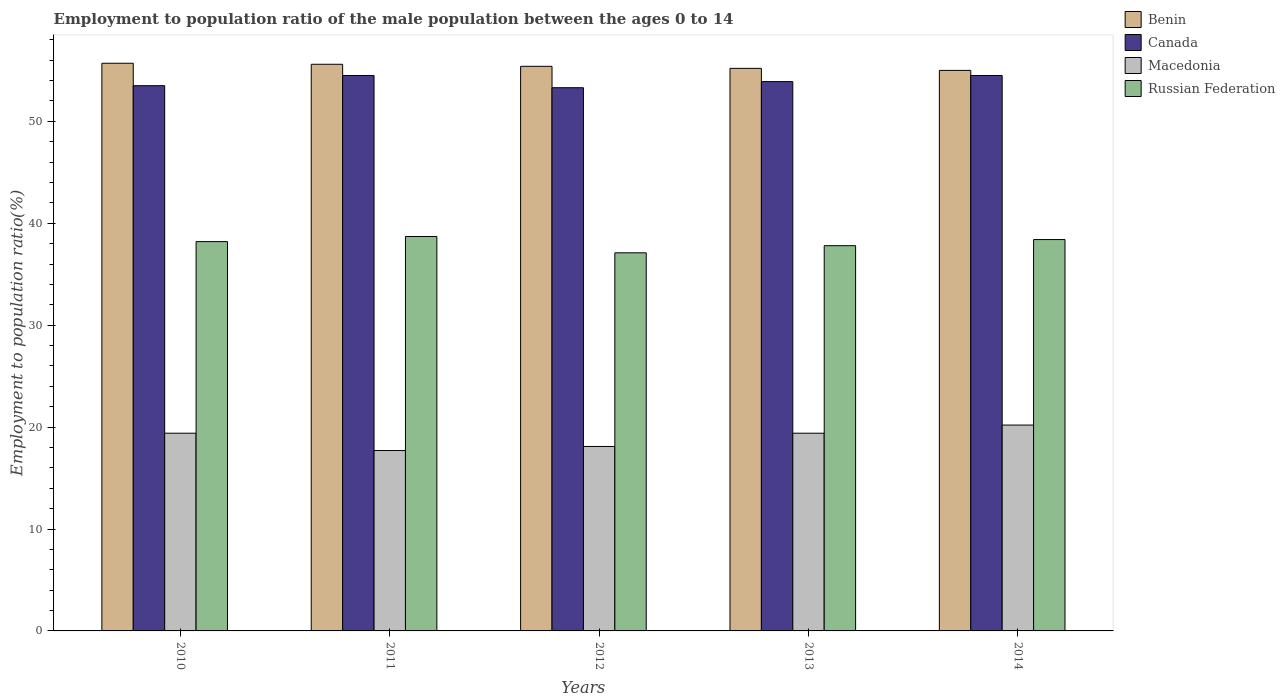How many different coloured bars are there?
Offer a terse response. 4. Are the number of bars per tick equal to the number of legend labels?
Your answer should be very brief. Yes. Are the number of bars on each tick of the X-axis equal?
Offer a very short reply. Yes. How many bars are there on the 1st tick from the left?
Keep it short and to the point. 4. How many bars are there on the 5th tick from the right?
Keep it short and to the point. 4. What is the label of the 3rd group of bars from the left?
Make the answer very short. 2012. What is the employment to population ratio in Benin in 2013?
Ensure brevity in your answer.  55.2. Across all years, what is the maximum employment to population ratio in Macedonia?
Offer a very short reply. 20.2. In which year was the employment to population ratio in Russian Federation maximum?
Keep it short and to the point. 2011. In which year was the employment to population ratio in Benin minimum?
Your answer should be compact. 2014. What is the total employment to population ratio in Russian Federation in the graph?
Offer a very short reply. 190.2. What is the difference between the employment to population ratio in Russian Federation in 2012 and that in 2013?
Your answer should be very brief. -0.7. What is the difference between the employment to population ratio in Canada in 2010 and the employment to population ratio in Benin in 2012?
Make the answer very short. -1.9. What is the average employment to population ratio in Benin per year?
Give a very brief answer. 55.38. In the year 2014, what is the difference between the employment to population ratio in Macedonia and employment to population ratio in Canada?
Your response must be concise. -34.3. In how many years, is the employment to population ratio in Benin greater than 30 %?
Your answer should be compact. 5. What is the ratio of the employment to population ratio in Canada in 2012 to that in 2014?
Give a very brief answer. 0.98. Is the difference between the employment to population ratio in Macedonia in 2013 and 2014 greater than the difference between the employment to population ratio in Canada in 2013 and 2014?
Make the answer very short. No. What is the difference between the highest and the second highest employment to population ratio in Canada?
Provide a short and direct response. 0. What is the difference between the highest and the lowest employment to population ratio in Benin?
Give a very brief answer. 0.7. In how many years, is the employment to population ratio in Canada greater than the average employment to population ratio in Canada taken over all years?
Make the answer very short. 2. Is it the case that in every year, the sum of the employment to population ratio in Russian Federation and employment to population ratio in Canada is greater than the sum of employment to population ratio in Macedonia and employment to population ratio in Benin?
Keep it short and to the point. No. What does the 3rd bar from the left in 2010 represents?
Ensure brevity in your answer.  Macedonia. What does the 1st bar from the right in 2011 represents?
Ensure brevity in your answer.  Russian Federation. Is it the case that in every year, the sum of the employment to population ratio in Macedonia and employment to population ratio in Russian Federation is greater than the employment to population ratio in Benin?
Give a very brief answer. No. How many bars are there?
Your answer should be compact. 20. Are the values on the major ticks of Y-axis written in scientific E-notation?
Keep it short and to the point. No. What is the title of the graph?
Provide a succinct answer. Employment to population ratio of the male population between the ages 0 to 14. What is the Employment to population ratio(%) in Benin in 2010?
Ensure brevity in your answer.  55.7. What is the Employment to population ratio(%) of Canada in 2010?
Offer a terse response. 53.5. What is the Employment to population ratio(%) in Macedonia in 2010?
Make the answer very short. 19.4. What is the Employment to population ratio(%) in Russian Federation in 2010?
Make the answer very short. 38.2. What is the Employment to population ratio(%) in Benin in 2011?
Provide a short and direct response. 55.6. What is the Employment to population ratio(%) of Canada in 2011?
Your answer should be compact. 54.5. What is the Employment to population ratio(%) of Macedonia in 2011?
Your response must be concise. 17.7. What is the Employment to population ratio(%) in Russian Federation in 2011?
Provide a short and direct response. 38.7. What is the Employment to population ratio(%) in Benin in 2012?
Offer a very short reply. 55.4. What is the Employment to population ratio(%) of Canada in 2012?
Your answer should be compact. 53.3. What is the Employment to population ratio(%) of Macedonia in 2012?
Provide a succinct answer. 18.1. What is the Employment to population ratio(%) of Russian Federation in 2012?
Offer a very short reply. 37.1. What is the Employment to population ratio(%) of Benin in 2013?
Make the answer very short. 55.2. What is the Employment to population ratio(%) in Canada in 2013?
Offer a terse response. 53.9. What is the Employment to population ratio(%) in Macedonia in 2013?
Ensure brevity in your answer.  19.4. What is the Employment to population ratio(%) in Russian Federation in 2013?
Offer a terse response. 37.8. What is the Employment to population ratio(%) of Benin in 2014?
Make the answer very short. 55. What is the Employment to population ratio(%) of Canada in 2014?
Ensure brevity in your answer.  54.5. What is the Employment to population ratio(%) of Macedonia in 2014?
Give a very brief answer. 20.2. What is the Employment to population ratio(%) of Russian Federation in 2014?
Provide a succinct answer. 38.4. Across all years, what is the maximum Employment to population ratio(%) in Benin?
Give a very brief answer. 55.7. Across all years, what is the maximum Employment to population ratio(%) of Canada?
Provide a succinct answer. 54.5. Across all years, what is the maximum Employment to population ratio(%) of Macedonia?
Your answer should be very brief. 20.2. Across all years, what is the maximum Employment to population ratio(%) of Russian Federation?
Offer a very short reply. 38.7. Across all years, what is the minimum Employment to population ratio(%) in Benin?
Offer a terse response. 55. Across all years, what is the minimum Employment to population ratio(%) in Canada?
Ensure brevity in your answer.  53.3. Across all years, what is the minimum Employment to population ratio(%) of Macedonia?
Ensure brevity in your answer.  17.7. Across all years, what is the minimum Employment to population ratio(%) of Russian Federation?
Keep it short and to the point. 37.1. What is the total Employment to population ratio(%) of Benin in the graph?
Keep it short and to the point. 276.9. What is the total Employment to population ratio(%) of Canada in the graph?
Your answer should be compact. 269.7. What is the total Employment to population ratio(%) of Macedonia in the graph?
Your answer should be very brief. 94.8. What is the total Employment to population ratio(%) of Russian Federation in the graph?
Make the answer very short. 190.2. What is the difference between the Employment to population ratio(%) of Benin in 2010 and that in 2011?
Your answer should be compact. 0.1. What is the difference between the Employment to population ratio(%) of Canada in 2010 and that in 2011?
Keep it short and to the point. -1. What is the difference between the Employment to population ratio(%) of Macedonia in 2010 and that in 2011?
Your response must be concise. 1.7. What is the difference between the Employment to population ratio(%) of Macedonia in 2010 and that in 2012?
Your answer should be very brief. 1.3. What is the difference between the Employment to population ratio(%) in Benin in 2010 and that in 2013?
Your answer should be very brief. 0.5. What is the difference between the Employment to population ratio(%) of Macedonia in 2010 and that in 2013?
Your answer should be very brief. 0. What is the difference between the Employment to population ratio(%) in Russian Federation in 2010 and that in 2013?
Offer a terse response. 0.4. What is the difference between the Employment to population ratio(%) in Benin in 2011 and that in 2012?
Your answer should be compact. 0.2. What is the difference between the Employment to population ratio(%) of Canada in 2011 and that in 2012?
Ensure brevity in your answer.  1.2. What is the difference between the Employment to population ratio(%) in Macedonia in 2011 and that in 2012?
Give a very brief answer. -0.4. What is the difference between the Employment to population ratio(%) in Russian Federation in 2011 and that in 2012?
Ensure brevity in your answer.  1.6. What is the difference between the Employment to population ratio(%) of Macedonia in 2011 and that in 2013?
Make the answer very short. -1.7. What is the difference between the Employment to population ratio(%) of Russian Federation in 2011 and that in 2013?
Make the answer very short. 0.9. What is the difference between the Employment to population ratio(%) in Benin in 2011 and that in 2014?
Offer a very short reply. 0.6. What is the difference between the Employment to population ratio(%) of Canada in 2011 and that in 2014?
Your answer should be very brief. 0. What is the difference between the Employment to population ratio(%) of Canada in 2012 and that in 2013?
Offer a terse response. -0.6. What is the difference between the Employment to population ratio(%) of Macedonia in 2012 and that in 2013?
Keep it short and to the point. -1.3. What is the difference between the Employment to population ratio(%) in Russian Federation in 2012 and that in 2013?
Your answer should be compact. -0.7. What is the difference between the Employment to population ratio(%) of Benin in 2012 and that in 2014?
Keep it short and to the point. 0.4. What is the difference between the Employment to population ratio(%) in Canada in 2012 and that in 2014?
Offer a terse response. -1.2. What is the difference between the Employment to population ratio(%) in Canada in 2010 and the Employment to population ratio(%) in Macedonia in 2011?
Offer a very short reply. 35.8. What is the difference between the Employment to population ratio(%) in Canada in 2010 and the Employment to population ratio(%) in Russian Federation in 2011?
Provide a succinct answer. 14.8. What is the difference between the Employment to population ratio(%) in Macedonia in 2010 and the Employment to population ratio(%) in Russian Federation in 2011?
Offer a very short reply. -19.3. What is the difference between the Employment to population ratio(%) in Benin in 2010 and the Employment to population ratio(%) in Macedonia in 2012?
Provide a succinct answer. 37.6. What is the difference between the Employment to population ratio(%) of Canada in 2010 and the Employment to population ratio(%) of Macedonia in 2012?
Make the answer very short. 35.4. What is the difference between the Employment to population ratio(%) of Canada in 2010 and the Employment to population ratio(%) of Russian Federation in 2012?
Offer a very short reply. 16.4. What is the difference between the Employment to population ratio(%) in Macedonia in 2010 and the Employment to population ratio(%) in Russian Federation in 2012?
Ensure brevity in your answer.  -17.7. What is the difference between the Employment to population ratio(%) in Benin in 2010 and the Employment to population ratio(%) in Macedonia in 2013?
Your answer should be very brief. 36.3. What is the difference between the Employment to population ratio(%) in Benin in 2010 and the Employment to population ratio(%) in Russian Federation in 2013?
Offer a terse response. 17.9. What is the difference between the Employment to population ratio(%) of Canada in 2010 and the Employment to population ratio(%) of Macedonia in 2013?
Give a very brief answer. 34.1. What is the difference between the Employment to population ratio(%) of Canada in 2010 and the Employment to population ratio(%) of Russian Federation in 2013?
Offer a terse response. 15.7. What is the difference between the Employment to population ratio(%) in Macedonia in 2010 and the Employment to population ratio(%) in Russian Federation in 2013?
Offer a terse response. -18.4. What is the difference between the Employment to population ratio(%) of Benin in 2010 and the Employment to population ratio(%) of Canada in 2014?
Ensure brevity in your answer.  1.2. What is the difference between the Employment to population ratio(%) of Benin in 2010 and the Employment to population ratio(%) of Macedonia in 2014?
Keep it short and to the point. 35.5. What is the difference between the Employment to population ratio(%) of Benin in 2010 and the Employment to population ratio(%) of Russian Federation in 2014?
Your answer should be very brief. 17.3. What is the difference between the Employment to population ratio(%) in Canada in 2010 and the Employment to population ratio(%) in Macedonia in 2014?
Offer a very short reply. 33.3. What is the difference between the Employment to population ratio(%) of Macedonia in 2010 and the Employment to population ratio(%) of Russian Federation in 2014?
Your answer should be very brief. -19. What is the difference between the Employment to population ratio(%) of Benin in 2011 and the Employment to population ratio(%) of Macedonia in 2012?
Make the answer very short. 37.5. What is the difference between the Employment to population ratio(%) in Benin in 2011 and the Employment to population ratio(%) in Russian Federation in 2012?
Offer a terse response. 18.5. What is the difference between the Employment to population ratio(%) of Canada in 2011 and the Employment to population ratio(%) of Macedonia in 2012?
Your answer should be compact. 36.4. What is the difference between the Employment to population ratio(%) of Macedonia in 2011 and the Employment to population ratio(%) of Russian Federation in 2012?
Your answer should be very brief. -19.4. What is the difference between the Employment to population ratio(%) in Benin in 2011 and the Employment to population ratio(%) in Macedonia in 2013?
Provide a short and direct response. 36.2. What is the difference between the Employment to population ratio(%) of Canada in 2011 and the Employment to population ratio(%) of Macedonia in 2013?
Give a very brief answer. 35.1. What is the difference between the Employment to population ratio(%) in Canada in 2011 and the Employment to population ratio(%) in Russian Federation in 2013?
Ensure brevity in your answer.  16.7. What is the difference between the Employment to population ratio(%) in Macedonia in 2011 and the Employment to population ratio(%) in Russian Federation in 2013?
Offer a terse response. -20.1. What is the difference between the Employment to population ratio(%) in Benin in 2011 and the Employment to population ratio(%) in Canada in 2014?
Your answer should be very brief. 1.1. What is the difference between the Employment to population ratio(%) of Benin in 2011 and the Employment to population ratio(%) of Macedonia in 2014?
Give a very brief answer. 35.4. What is the difference between the Employment to population ratio(%) in Benin in 2011 and the Employment to population ratio(%) in Russian Federation in 2014?
Give a very brief answer. 17.2. What is the difference between the Employment to population ratio(%) of Canada in 2011 and the Employment to population ratio(%) of Macedonia in 2014?
Make the answer very short. 34.3. What is the difference between the Employment to population ratio(%) of Macedonia in 2011 and the Employment to population ratio(%) of Russian Federation in 2014?
Make the answer very short. -20.7. What is the difference between the Employment to population ratio(%) in Benin in 2012 and the Employment to population ratio(%) in Canada in 2013?
Provide a succinct answer. 1.5. What is the difference between the Employment to population ratio(%) of Benin in 2012 and the Employment to population ratio(%) of Russian Federation in 2013?
Make the answer very short. 17.6. What is the difference between the Employment to population ratio(%) in Canada in 2012 and the Employment to population ratio(%) in Macedonia in 2013?
Give a very brief answer. 33.9. What is the difference between the Employment to population ratio(%) in Macedonia in 2012 and the Employment to population ratio(%) in Russian Federation in 2013?
Offer a very short reply. -19.7. What is the difference between the Employment to population ratio(%) in Benin in 2012 and the Employment to population ratio(%) in Canada in 2014?
Ensure brevity in your answer.  0.9. What is the difference between the Employment to population ratio(%) in Benin in 2012 and the Employment to population ratio(%) in Macedonia in 2014?
Your response must be concise. 35.2. What is the difference between the Employment to population ratio(%) of Canada in 2012 and the Employment to population ratio(%) of Macedonia in 2014?
Offer a terse response. 33.1. What is the difference between the Employment to population ratio(%) in Macedonia in 2012 and the Employment to population ratio(%) in Russian Federation in 2014?
Your answer should be very brief. -20.3. What is the difference between the Employment to population ratio(%) of Benin in 2013 and the Employment to population ratio(%) of Russian Federation in 2014?
Your response must be concise. 16.8. What is the difference between the Employment to population ratio(%) in Canada in 2013 and the Employment to population ratio(%) in Macedonia in 2014?
Offer a very short reply. 33.7. What is the average Employment to population ratio(%) of Benin per year?
Your answer should be compact. 55.38. What is the average Employment to population ratio(%) of Canada per year?
Your response must be concise. 53.94. What is the average Employment to population ratio(%) of Macedonia per year?
Your answer should be compact. 18.96. What is the average Employment to population ratio(%) in Russian Federation per year?
Make the answer very short. 38.04. In the year 2010, what is the difference between the Employment to population ratio(%) of Benin and Employment to population ratio(%) of Macedonia?
Keep it short and to the point. 36.3. In the year 2010, what is the difference between the Employment to population ratio(%) of Canada and Employment to population ratio(%) of Macedonia?
Offer a terse response. 34.1. In the year 2010, what is the difference between the Employment to population ratio(%) of Macedonia and Employment to population ratio(%) of Russian Federation?
Keep it short and to the point. -18.8. In the year 2011, what is the difference between the Employment to population ratio(%) of Benin and Employment to population ratio(%) of Canada?
Your answer should be compact. 1.1. In the year 2011, what is the difference between the Employment to population ratio(%) in Benin and Employment to population ratio(%) in Macedonia?
Give a very brief answer. 37.9. In the year 2011, what is the difference between the Employment to population ratio(%) of Canada and Employment to population ratio(%) of Macedonia?
Provide a succinct answer. 36.8. In the year 2011, what is the difference between the Employment to population ratio(%) of Canada and Employment to population ratio(%) of Russian Federation?
Make the answer very short. 15.8. In the year 2012, what is the difference between the Employment to population ratio(%) of Benin and Employment to population ratio(%) of Canada?
Give a very brief answer. 2.1. In the year 2012, what is the difference between the Employment to population ratio(%) of Benin and Employment to population ratio(%) of Macedonia?
Your answer should be very brief. 37.3. In the year 2012, what is the difference between the Employment to population ratio(%) of Canada and Employment to population ratio(%) of Macedonia?
Give a very brief answer. 35.2. In the year 2012, what is the difference between the Employment to population ratio(%) of Canada and Employment to population ratio(%) of Russian Federation?
Provide a succinct answer. 16.2. In the year 2013, what is the difference between the Employment to population ratio(%) in Benin and Employment to population ratio(%) in Canada?
Provide a succinct answer. 1.3. In the year 2013, what is the difference between the Employment to population ratio(%) in Benin and Employment to population ratio(%) in Macedonia?
Give a very brief answer. 35.8. In the year 2013, what is the difference between the Employment to population ratio(%) in Benin and Employment to population ratio(%) in Russian Federation?
Keep it short and to the point. 17.4. In the year 2013, what is the difference between the Employment to population ratio(%) of Canada and Employment to population ratio(%) of Macedonia?
Your answer should be compact. 34.5. In the year 2013, what is the difference between the Employment to population ratio(%) in Macedonia and Employment to population ratio(%) in Russian Federation?
Keep it short and to the point. -18.4. In the year 2014, what is the difference between the Employment to population ratio(%) of Benin and Employment to population ratio(%) of Canada?
Give a very brief answer. 0.5. In the year 2014, what is the difference between the Employment to population ratio(%) in Benin and Employment to population ratio(%) in Macedonia?
Make the answer very short. 34.8. In the year 2014, what is the difference between the Employment to population ratio(%) of Canada and Employment to population ratio(%) of Macedonia?
Provide a succinct answer. 34.3. In the year 2014, what is the difference between the Employment to population ratio(%) in Canada and Employment to population ratio(%) in Russian Federation?
Your answer should be compact. 16.1. In the year 2014, what is the difference between the Employment to population ratio(%) of Macedonia and Employment to population ratio(%) of Russian Federation?
Your answer should be compact. -18.2. What is the ratio of the Employment to population ratio(%) in Benin in 2010 to that in 2011?
Offer a very short reply. 1. What is the ratio of the Employment to population ratio(%) of Canada in 2010 to that in 2011?
Provide a short and direct response. 0.98. What is the ratio of the Employment to population ratio(%) in Macedonia in 2010 to that in 2011?
Offer a terse response. 1.1. What is the ratio of the Employment to population ratio(%) of Russian Federation in 2010 to that in 2011?
Your response must be concise. 0.99. What is the ratio of the Employment to population ratio(%) in Benin in 2010 to that in 2012?
Keep it short and to the point. 1.01. What is the ratio of the Employment to population ratio(%) in Canada in 2010 to that in 2012?
Your answer should be compact. 1. What is the ratio of the Employment to population ratio(%) of Macedonia in 2010 to that in 2012?
Your answer should be very brief. 1.07. What is the ratio of the Employment to population ratio(%) in Russian Federation in 2010 to that in 2012?
Provide a short and direct response. 1.03. What is the ratio of the Employment to population ratio(%) in Benin in 2010 to that in 2013?
Make the answer very short. 1.01. What is the ratio of the Employment to population ratio(%) of Macedonia in 2010 to that in 2013?
Make the answer very short. 1. What is the ratio of the Employment to population ratio(%) in Russian Federation in 2010 to that in 2013?
Your response must be concise. 1.01. What is the ratio of the Employment to population ratio(%) of Benin in 2010 to that in 2014?
Your answer should be compact. 1.01. What is the ratio of the Employment to population ratio(%) of Canada in 2010 to that in 2014?
Offer a terse response. 0.98. What is the ratio of the Employment to population ratio(%) of Macedonia in 2010 to that in 2014?
Keep it short and to the point. 0.96. What is the ratio of the Employment to population ratio(%) of Canada in 2011 to that in 2012?
Your answer should be very brief. 1.02. What is the ratio of the Employment to population ratio(%) in Macedonia in 2011 to that in 2012?
Provide a short and direct response. 0.98. What is the ratio of the Employment to population ratio(%) in Russian Federation in 2011 to that in 2012?
Your answer should be very brief. 1.04. What is the ratio of the Employment to population ratio(%) in Canada in 2011 to that in 2013?
Provide a short and direct response. 1.01. What is the ratio of the Employment to population ratio(%) of Macedonia in 2011 to that in 2013?
Offer a very short reply. 0.91. What is the ratio of the Employment to population ratio(%) in Russian Federation in 2011 to that in 2013?
Provide a short and direct response. 1.02. What is the ratio of the Employment to population ratio(%) in Benin in 2011 to that in 2014?
Your answer should be very brief. 1.01. What is the ratio of the Employment to population ratio(%) of Canada in 2011 to that in 2014?
Make the answer very short. 1. What is the ratio of the Employment to population ratio(%) of Macedonia in 2011 to that in 2014?
Your answer should be very brief. 0.88. What is the ratio of the Employment to population ratio(%) in Canada in 2012 to that in 2013?
Provide a succinct answer. 0.99. What is the ratio of the Employment to population ratio(%) of Macedonia in 2012 to that in 2013?
Your response must be concise. 0.93. What is the ratio of the Employment to population ratio(%) in Russian Federation in 2012 to that in 2013?
Ensure brevity in your answer.  0.98. What is the ratio of the Employment to population ratio(%) of Benin in 2012 to that in 2014?
Offer a terse response. 1.01. What is the ratio of the Employment to population ratio(%) in Macedonia in 2012 to that in 2014?
Your answer should be compact. 0.9. What is the ratio of the Employment to population ratio(%) of Russian Federation in 2012 to that in 2014?
Keep it short and to the point. 0.97. What is the ratio of the Employment to population ratio(%) in Benin in 2013 to that in 2014?
Your answer should be very brief. 1. What is the ratio of the Employment to population ratio(%) of Canada in 2013 to that in 2014?
Your response must be concise. 0.99. What is the ratio of the Employment to population ratio(%) in Macedonia in 2013 to that in 2014?
Make the answer very short. 0.96. What is the ratio of the Employment to population ratio(%) of Russian Federation in 2013 to that in 2014?
Your response must be concise. 0.98. What is the difference between the highest and the second highest Employment to population ratio(%) of Benin?
Ensure brevity in your answer.  0.1. What is the difference between the highest and the second highest Employment to population ratio(%) in Canada?
Offer a very short reply. 0. What is the difference between the highest and the second highest Employment to population ratio(%) in Russian Federation?
Ensure brevity in your answer.  0.3. What is the difference between the highest and the lowest Employment to population ratio(%) in Benin?
Provide a short and direct response. 0.7. What is the difference between the highest and the lowest Employment to population ratio(%) in Russian Federation?
Your answer should be very brief. 1.6. 